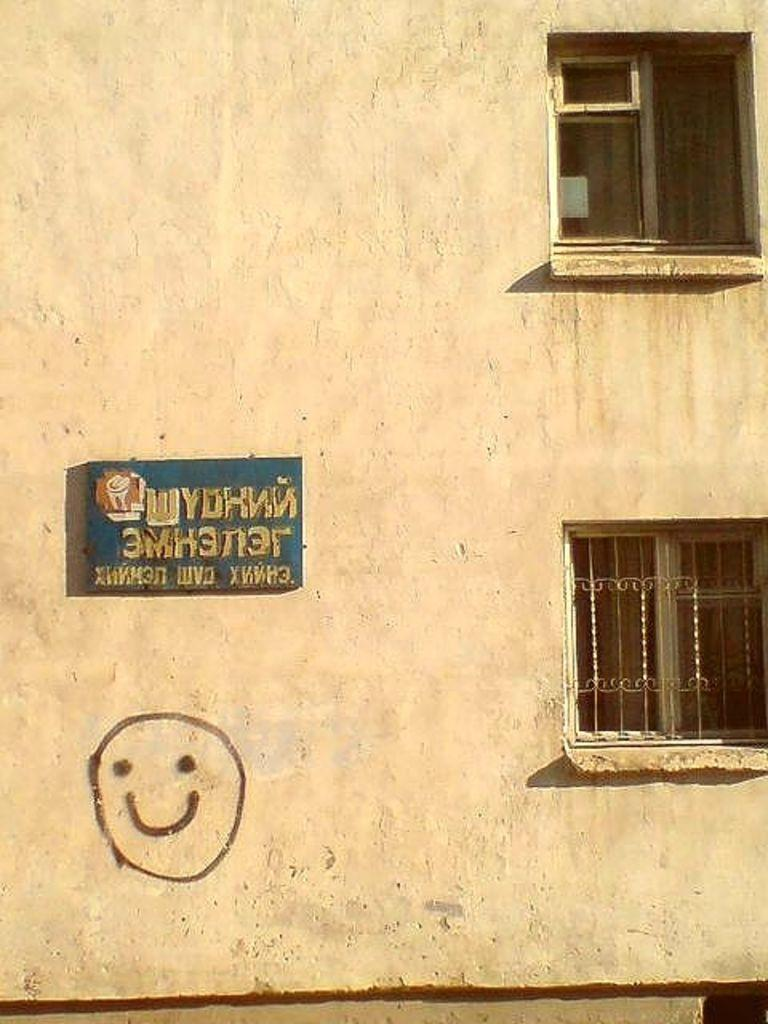What type of openings can be seen in the image? There are windows in the image. What object is present in the image that can be used for displaying information or messages? There is a board in the image. What type of artwork or design can be seen on the wall in the image? There is a drawing on the wall in the image. Can you see the ocean from the windows in the image? There is no reference to an ocean or any water body in the image, so it cannot be determined if it is visible from the windows. What type of beam is supporting the board in the image? There is no beam present in the image; only the board and windows are mentioned. 